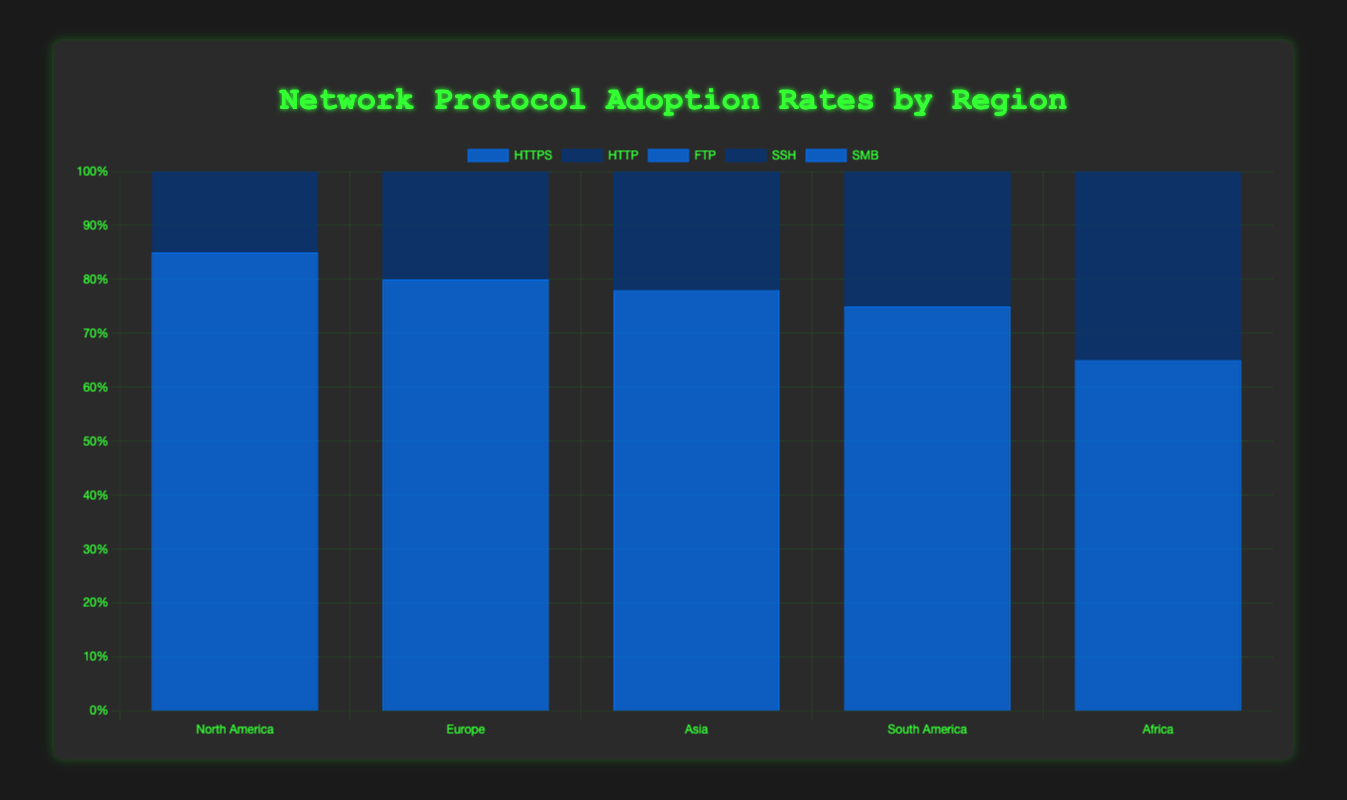Which region has the highest HTTPS adoption rate? Looking at the bar chart, the highest HTTPS adoption rate is observed in North America, which has an adoption rate of 85%.
Answer: North America What is the total adoption rate for SSH across all regions? To find the total adoption rate for SSH, we sum the values for each region: North America (75), Europe (70), Asia (65), South America (60), and Africa (50). Therefore, 75 + 70 + 65 + 60 + 50 = 320.
Answer: 320 Compare the adoption rates of FTP between Europe and South America. Which one is higher? Europe has an FTP adoption rate of 50%, and South America has an FTP adoption rate of 60%. Therefore, South America has a higher FTP adoption rate.
Answer: South America What is the average adoption rate of SMB in the regions shown in the chart? To find the average adoption rate of SMB, add the adoption rates in all regions and divide by the number of regions: (North America 60 + Europe 55 + Asia 50 + South America 50 + Africa 45) / 5 = 260 / 5 = 52.
Answer: 52 Which protocol has the lowest adoption rate in Asia? According to the bar heights, SMB has the lowest adoption rate in Asia, with an adoption rate of 50%.
Answer: SMB How much higher is the HTTPS adoption rate in North America compared to Africa? The adoption rate for HTTPS in North America is 85%, whereas it is 65% in Africa. The difference is 85% - 65% = 20%.
Answer: 20% Which region has the smallest difference in adoption rates between HTTP and HTTPS? To calculate the differences: North America (85-70=15), Europe (80-65=15), Asia (78-60=18), South America (75-55=20), and Africa (65-50=15). The smallest difference, 15%, appears in North America, Europe, and Africa.
Answer: North America, Europe, and Africa What is the combined adoption rate of HTTP and HTTPS in South America? The combined adoption rates of HTTP (55) and HTTPS (75) in South America is 55 + 75 = 130.
Answer: 130 Which protocol shows the least variance in adoption rates across all regions? By visually comparing the lengths of the bars, FTP appears to have the least variance, as its range of adoption rates across regions remains relatively consistent (45-60%).
Answer: FTP 